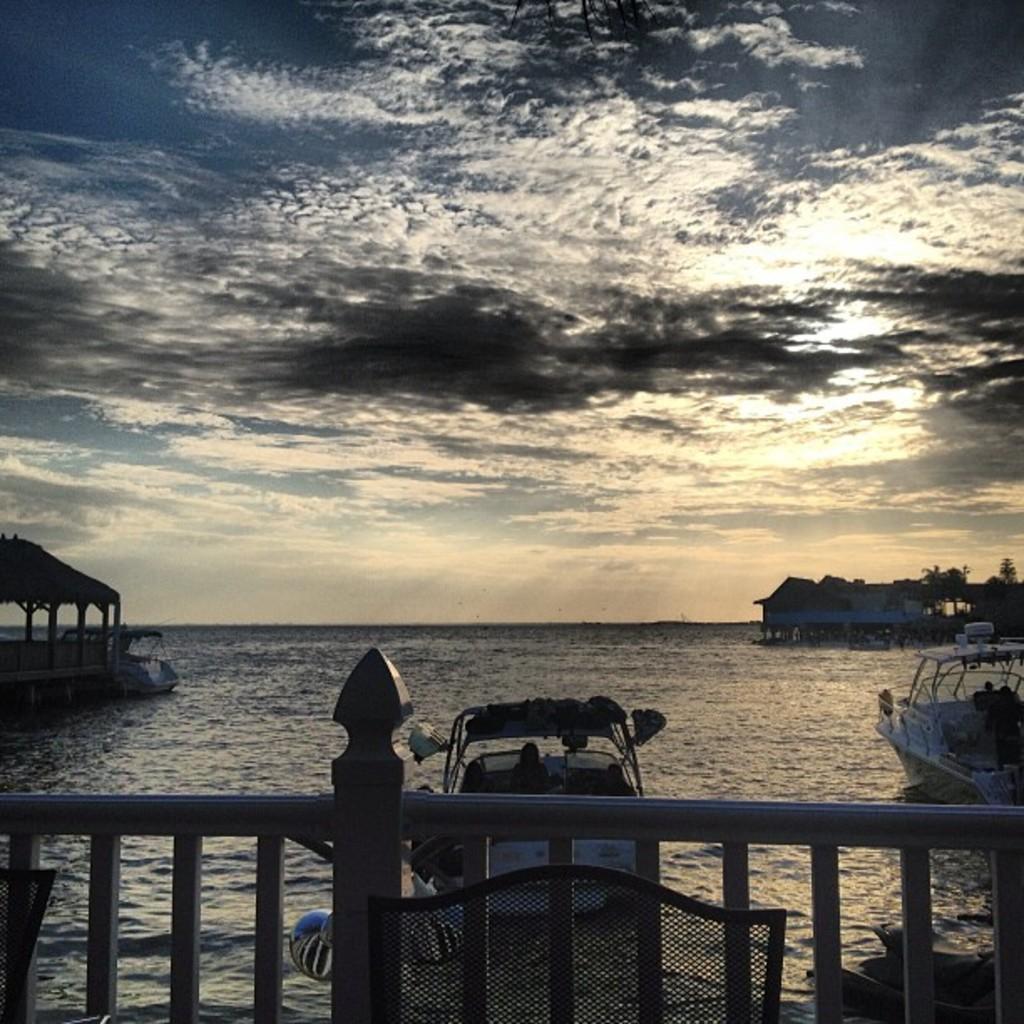How would you summarize this image in a sentence or two? In this picture we can see boats, some persons, sheds, trees, water are there. At the top of the image clouds are present in the sky. At the bottom of the image we can see fencing, chair are there. 